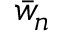<formula> <loc_0><loc_0><loc_500><loc_500>\bar { w } _ { n }</formula> 